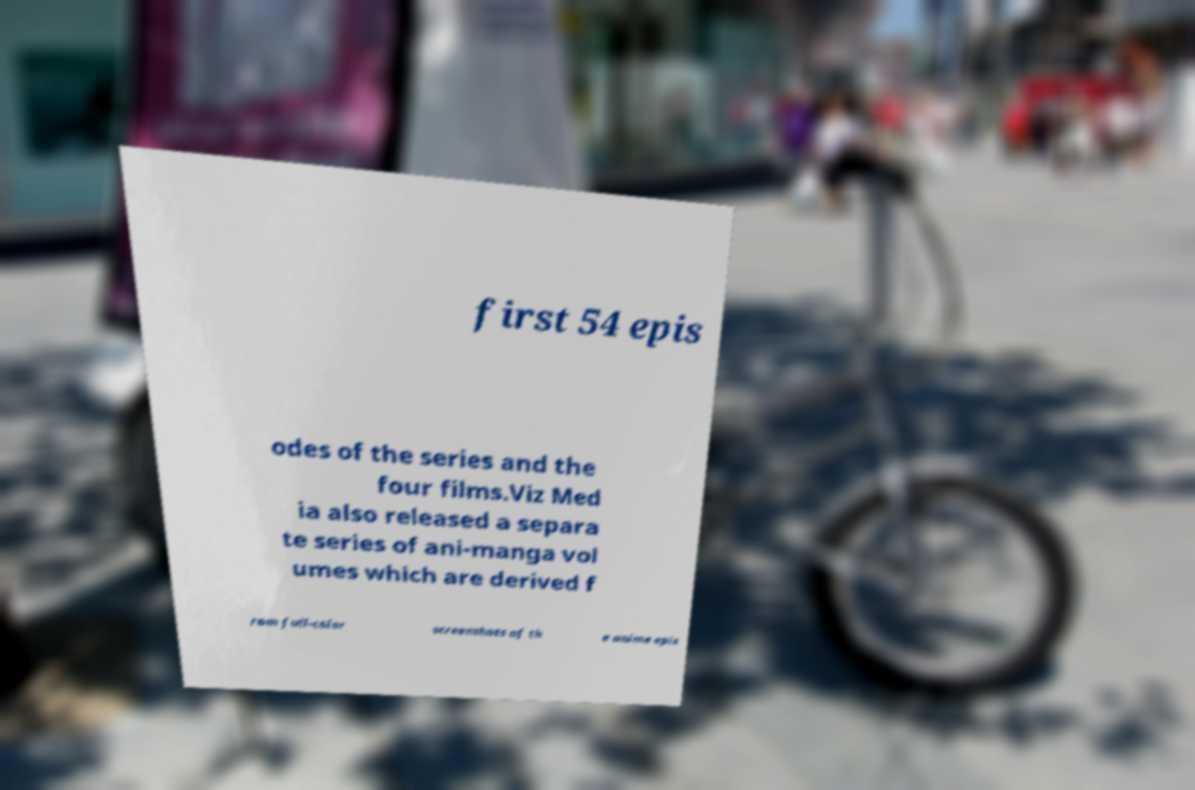For documentation purposes, I need the text within this image transcribed. Could you provide that? first 54 epis odes of the series and the four films.Viz Med ia also released a separa te series of ani-manga vol umes which are derived f rom full-color screenshots of th e anime epis 